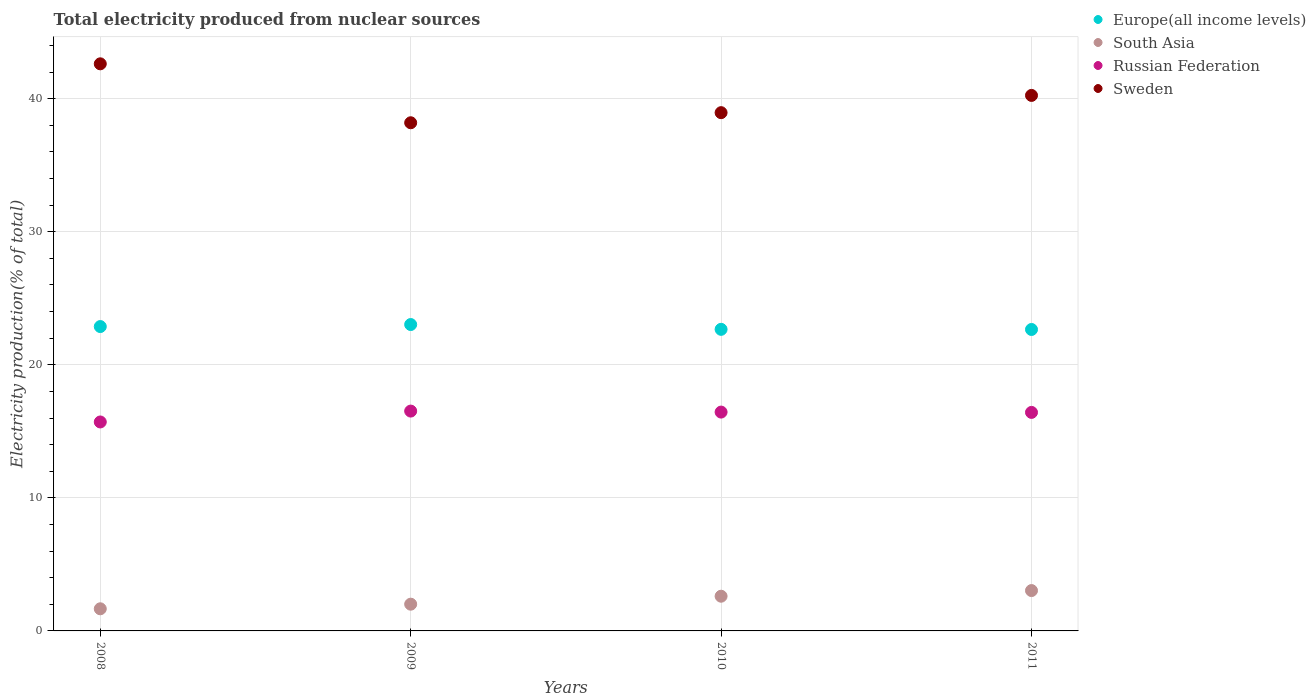Is the number of dotlines equal to the number of legend labels?
Your answer should be very brief. Yes. What is the total electricity produced in Russian Federation in 2011?
Your answer should be very brief. 16.42. Across all years, what is the maximum total electricity produced in Sweden?
Your answer should be very brief. 42.62. Across all years, what is the minimum total electricity produced in South Asia?
Provide a short and direct response. 1.66. In which year was the total electricity produced in Sweden maximum?
Your answer should be compact. 2008. In which year was the total electricity produced in Europe(all income levels) minimum?
Provide a succinct answer. 2011. What is the total total electricity produced in Sweden in the graph?
Keep it short and to the point. 160.02. What is the difference between the total electricity produced in Europe(all income levels) in 2008 and that in 2010?
Give a very brief answer. 0.21. What is the difference between the total electricity produced in Russian Federation in 2011 and the total electricity produced in Europe(all income levels) in 2009?
Your answer should be very brief. -6.6. What is the average total electricity produced in South Asia per year?
Offer a very short reply. 2.33. In the year 2009, what is the difference between the total electricity produced in Sweden and total electricity produced in Russian Federation?
Your answer should be compact. 21.67. In how many years, is the total electricity produced in South Asia greater than 20 %?
Keep it short and to the point. 0. What is the ratio of the total electricity produced in Sweden in 2010 to that in 2011?
Your answer should be very brief. 0.97. Is the total electricity produced in Europe(all income levels) in 2010 less than that in 2011?
Provide a succinct answer. No. Is the difference between the total electricity produced in Sweden in 2008 and 2011 greater than the difference between the total electricity produced in Russian Federation in 2008 and 2011?
Make the answer very short. Yes. What is the difference between the highest and the second highest total electricity produced in South Asia?
Offer a very short reply. 0.42. What is the difference between the highest and the lowest total electricity produced in Sweden?
Give a very brief answer. 4.43. Does the total electricity produced in Europe(all income levels) monotonically increase over the years?
Keep it short and to the point. No. What is the difference between two consecutive major ticks on the Y-axis?
Ensure brevity in your answer.  10. Does the graph contain grids?
Provide a succinct answer. Yes. Where does the legend appear in the graph?
Provide a succinct answer. Top right. How many legend labels are there?
Your response must be concise. 4. How are the legend labels stacked?
Give a very brief answer. Vertical. What is the title of the graph?
Your answer should be very brief. Total electricity produced from nuclear sources. Does "Thailand" appear as one of the legend labels in the graph?
Provide a succinct answer. No. What is the label or title of the X-axis?
Offer a terse response. Years. What is the label or title of the Y-axis?
Offer a very short reply. Electricity production(% of total). What is the Electricity production(% of total) of Europe(all income levels) in 2008?
Ensure brevity in your answer.  22.88. What is the Electricity production(% of total) in South Asia in 2008?
Give a very brief answer. 1.66. What is the Electricity production(% of total) in Russian Federation in 2008?
Give a very brief answer. 15.7. What is the Electricity production(% of total) in Sweden in 2008?
Give a very brief answer. 42.62. What is the Electricity production(% of total) in Europe(all income levels) in 2009?
Keep it short and to the point. 23.03. What is the Electricity production(% of total) of South Asia in 2009?
Provide a short and direct response. 2.01. What is the Electricity production(% of total) in Russian Federation in 2009?
Your answer should be very brief. 16.52. What is the Electricity production(% of total) of Sweden in 2009?
Provide a succinct answer. 38.19. What is the Electricity production(% of total) of Europe(all income levels) in 2010?
Provide a succinct answer. 22.67. What is the Electricity production(% of total) of South Asia in 2010?
Offer a very short reply. 2.61. What is the Electricity production(% of total) of Russian Federation in 2010?
Offer a terse response. 16.45. What is the Electricity production(% of total) of Sweden in 2010?
Keep it short and to the point. 38.95. What is the Electricity production(% of total) of Europe(all income levels) in 2011?
Offer a terse response. 22.66. What is the Electricity production(% of total) of South Asia in 2011?
Provide a short and direct response. 3.03. What is the Electricity production(% of total) of Russian Federation in 2011?
Offer a very short reply. 16.42. What is the Electricity production(% of total) of Sweden in 2011?
Make the answer very short. 40.25. Across all years, what is the maximum Electricity production(% of total) in Europe(all income levels)?
Offer a terse response. 23.03. Across all years, what is the maximum Electricity production(% of total) of South Asia?
Give a very brief answer. 3.03. Across all years, what is the maximum Electricity production(% of total) in Russian Federation?
Offer a very short reply. 16.52. Across all years, what is the maximum Electricity production(% of total) of Sweden?
Your answer should be very brief. 42.62. Across all years, what is the minimum Electricity production(% of total) of Europe(all income levels)?
Give a very brief answer. 22.66. Across all years, what is the minimum Electricity production(% of total) in South Asia?
Give a very brief answer. 1.66. Across all years, what is the minimum Electricity production(% of total) of Russian Federation?
Provide a short and direct response. 15.7. Across all years, what is the minimum Electricity production(% of total) of Sweden?
Make the answer very short. 38.19. What is the total Electricity production(% of total) of Europe(all income levels) in the graph?
Provide a succinct answer. 91.23. What is the total Electricity production(% of total) of South Asia in the graph?
Provide a succinct answer. 9.31. What is the total Electricity production(% of total) in Russian Federation in the graph?
Provide a short and direct response. 65.1. What is the total Electricity production(% of total) in Sweden in the graph?
Make the answer very short. 160.02. What is the difference between the Electricity production(% of total) in Europe(all income levels) in 2008 and that in 2009?
Give a very brief answer. -0.15. What is the difference between the Electricity production(% of total) of South Asia in 2008 and that in 2009?
Offer a terse response. -0.35. What is the difference between the Electricity production(% of total) of Russian Federation in 2008 and that in 2009?
Your answer should be compact. -0.82. What is the difference between the Electricity production(% of total) of Sweden in 2008 and that in 2009?
Ensure brevity in your answer.  4.43. What is the difference between the Electricity production(% of total) of Europe(all income levels) in 2008 and that in 2010?
Provide a short and direct response. 0.21. What is the difference between the Electricity production(% of total) in South Asia in 2008 and that in 2010?
Keep it short and to the point. -0.94. What is the difference between the Electricity production(% of total) of Russian Federation in 2008 and that in 2010?
Provide a succinct answer. -0.74. What is the difference between the Electricity production(% of total) in Sweden in 2008 and that in 2010?
Ensure brevity in your answer.  3.67. What is the difference between the Electricity production(% of total) of Europe(all income levels) in 2008 and that in 2011?
Your response must be concise. 0.22. What is the difference between the Electricity production(% of total) in South Asia in 2008 and that in 2011?
Ensure brevity in your answer.  -1.37. What is the difference between the Electricity production(% of total) of Russian Federation in 2008 and that in 2011?
Provide a short and direct response. -0.72. What is the difference between the Electricity production(% of total) in Sweden in 2008 and that in 2011?
Your response must be concise. 2.37. What is the difference between the Electricity production(% of total) of Europe(all income levels) in 2009 and that in 2010?
Offer a terse response. 0.36. What is the difference between the Electricity production(% of total) of South Asia in 2009 and that in 2010?
Make the answer very short. -0.6. What is the difference between the Electricity production(% of total) of Russian Federation in 2009 and that in 2010?
Your answer should be very brief. 0.08. What is the difference between the Electricity production(% of total) in Sweden in 2009 and that in 2010?
Make the answer very short. -0.76. What is the difference between the Electricity production(% of total) of Europe(all income levels) in 2009 and that in 2011?
Your answer should be compact. 0.37. What is the difference between the Electricity production(% of total) in South Asia in 2009 and that in 2011?
Offer a terse response. -1.02. What is the difference between the Electricity production(% of total) of Russian Federation in 2009 and that in 2011?
Provide a succinct answer. 0.1. What is the difference between the Electricity production(% of total) of Sweden in 2009 and that in 2011?
Ensure brevity in your answer.  -2.06. What is the difference between the Electricity production(% of total) in Europe(all income levels) in 2010 and that in 2011?
Give a very brief answer. 0.01. What is the difference between the Electricity production(% of total) in South Asia in 2010 and that in 2011?
Your answer should be very brief. -0.42. What is the difference between the Electricity production(% of total) of Russian Federation in 2010 and that in 2011?
Your answer should be compact. 0.02. What is the difference between the Electricity production(% of total) in Sweden in 2010 and that in 2011?
Offer a very short reply. -1.3. What is the difference between the Electricity production(% of total) of Europe(all income levels) in 2008 and the Electricity production(% of total) of South Asia in 2009?
Give a very brief answer. 20.87. What is the difference between the Electricity production(% of total) of Europe(all income levels) in 2008 and the Electricity production(% of total) of Russian Federation in 2009?
Your answer should be compact. 6.35. What is the difference between the Electricity production(% of total) of Europe(all income levels) in 2008 and the Electricity production(% of total) of Sweden in 2009?
Your answer should be compact. -15.32. What is the difference between the Electricity production(% of total) in South Asia in 2008 and the Electricity production(% of total) in Russian Federation in 2009?
Offer a terse response. -14.86. What is the difference between the Electricity production(% of total) in South Asia in 2008 and the Electricity production(% of total) in Sweden in 2009?
Provide a succinct answer. -36.53. What is the difference between the Electricity production(% of total) in Russian Federation in 2008 and the Electricity production(% of total) in Sweden in 2009?
Your answer should be compact. -22.49. What is the difference between the Electricity production(% of total) in Europe(all income levels) in 2008 and the Electricity production(% of total) in South Asia in 2010?
Your answer should be compact. 20.27. What is the difference between the Electricity production(% of total) of Europe(all income levels) in 2008 and the Electricity production(% of total) of Russian Federation in 2010?
Offer a terse response. 6.43. What is the difference between the Electricity production(% of total) in Europe(all income levels) in 2008 and the Electricity production(% of total) in Sweden in 2010?
Provide a succinct answer. -16.08. What is the difference between the Electricity production(% of total) of South Asia in 2008 and the Electricity production(% of total) of Russian Federation in 2010?
Your response must be concise. -14.78. What is the difference between the Electricity production(% of total) of South Asia in 2008 and the Electricity production(% of total) of Sweden in 2010?
Offer a terse response. -37.29. What is the difference between the Electricity production(% of total) in Russian Federation in 2008 and the Electricity production(% of total) in Sweden in 2010?
Provide a short and direct response. -23.25. What is the difference between the Electricity production(% of total) in Europe(all income levels) in 2008 and the Electricity production(% of total) in South Asia in 2011?
Make the answer very short. 19.84. What is the difference between the Electricity production(% of total) in Europe(all income levels) in 2008 and the Electricity production(% of total) in Russian Federation in 2011?
Your answer should be compact. 6.45. What is the difference between the Electricity production(% of total) of Europe(all income levels) in 2008 and the Electricity production(% of total) of Sweden in 2011?
Provide a succinct answer. -17.37. What is the difference between the Electricity production(% of total) in South Asia in 2008 and the Electricity production(% of total) in Russian Federation in 2011?
Make the answer very short. -14.76. What is the difference between the Electricity production(% of total) in South Asia in 2008 and the Electricity production(% of total) in Sweden in 2011?
Keep it short and to the point. -38.59. What is the difference between the Electricity production(% of total) in Russian Federation in 2008 and the Electricity production(% of total) in Sweden in 2011?
Provide a short and direct response. -24.54. What is the difference between the Electricity production(% of total) of Europe(all income levels) in 2009 and the Electricity production(% of total) of South Asia in 2010?
Give a very brief answer. 20.42. What is the difference between the Electricity production(% of total) in Europe(all income levels) in 2009 and the Electricity production(% of total) in Russian Federation in 2010?
Your response must be concise. 6.58. What is the difference between the Electricity production(% of total) of Europe(all income levels) in 2009 and the Electricity production(% of total) of Sweden in 2010?
Provide a succinct answer. -15.92. What is the difference between the Electricity production(% of total) in South Asia in 2009 and the Electricity production(% of total) in Russian Federation in 2010?
Provide a succinct answer. -14.44. What is the difference between the Electricity production(% of total) of South Asia in 2009 and the Electricity production(% of total) of Sweden in 2010?
Provide a short and direct response. -36.94. What is the difference between the Electricity production(% of total) in Russian Federation in 2009 and the Electricity production(% of total) in Sweden in 2010?
Keep it short and to the point. -22.43. What is the difference between the Electricity production(% of total) of Europe(all income levels) in 2009 and the Electricity production(% of total) of South Asia in 2011?
Give a very brief answer. 20. What is the difference between the Electricity production(% of total) in Europe(all income levels) in 2009 and the Electricity production(% of total) in Russian Federation in 2011?
Your response must be concise. 6.6. What is the difference between the Electricity production(% of total) of Europe(all income levels) in 2009 and the Electricity production(% of total) of Sweden in 2011?
Ensure brevity in your answer.  -17.22. What is the difference between the Electricity production(% of total) in South Asia in 2009 and the Electricity production(% of total) in Russian Federation in 2011?
Provide a succinct answer. -14.41. What is the difference between the Electricity production(% of total) in South Asia in 2009 and the Electricity production(% of total) in Sweden in 2011?
Provide a short and direct response. -38.24. What is the difference between the Electricity production(% of total) of Russian Federation in 2009 and the Electricity production(% of total) of Sweden in 2011?
Provide a succinct answer. -23.73. What is the difference between the Electricity production(% of total) in Europe(all income levels) in 2010 and the Electricity production(% of total) in South Asia in 2011?
Your answer should be very brief. 19.63. What is the difference between the Electricity production(% of total) of Europe(all income levels) in 2010 and the Electricity production(% of total) of Russian Federation in 2011?
Ensure brevity in your answer.  6.24. What is the difference between the Electricity production(% of total) of Europe(all income levels) in 2010 and the Electricity production(% of total) of Sweden in 2011?
Keep it short and to the point. -17.58. What is the difference between the Electricity production(% of total) in South Asia in 2010 and the Electricity production(% of total) in Russian Federation in 2011?
Your response must be concise. -13.82. What is the difference between the Electricity production(% of total) of South Asia in 2010 and the Electricity production(% of total) of Sweden in 2011?
Ensure brevity in your answer.  -37.64. What is the difference between the Electricity production(% of total) of Russian Federation in 2010 and the Electricity production(% of total) of Sweden in 2011?
Your response must be concise. -23.8. What is the average Electricity production(% of total) of Europe(all income levels) per year?
Your response must be concise. 22.81. What is the average Electricity production(% of total) in South Asia per year?
Ensure brevity in your answer.  2.33. What is the average Electricity production(% of total) in Russian Federation per year?
Offer a very short reply. 16.27. What is the average Electricity production(% of total) in Sweden per year?
Offer a terse response. 40. In the year 2008, what is the difference between the Electricity production(% of total) of Europe(all income levels) and Electricity production(% of total) of South Asia?
Keep it short and to the point. 21.21. In the year 2008, what is the difference between the Electricity production(% of total) of Europe(all income levels) and Electricity production(% of total) of Russian Federation?
Provide a short and direct response. 7.17. In the year 2008, what is the difference between the Electricity production(% of total) of Europe(all income levels) and Electricity production(% of total) of Sweden?
Give a very brief answer. -19.75. In the year 2008, what is the difference between the Electricity production(% of total) of South Asia and Electricity production(% of total) of Russian Federation?
Ensure brevity in your answer.  -14.04. In the year 2008, what is the difference between the Electricity production(% of total) in South Asia and Electricity production(% of total) in Sweden?
Your response must be concise. -40.96. In the year 2008, what is the difference between the Electricity production(% of total) of Russian Federation and Electricity production(% of total) of Sweden?
Offer a terse response. -26.92. In the year 2009, what is the difference between the Electricity production(% of total) in Europe(all income levels) and Electricity production(% of total) in South Asia?
Offer a very short reply. 21.02. In the year 2009, what is the difference between the Electricity production(% of total) of Europe(all income levels) and Electricity production(% of total) of Russian Federation?
Your response must be concise. 6.5. In the year 2009, what is the difference between the Electricity production(% of total) of Europe(all income levels) and Electricity production(% of total) of Sweden?
Offer a very short reply. -15.16. In the year 2009, what is the difference between the Electricity production(% of total) of South Asia and Electricity production(% of total) of Russian Federation?
Ensure brevity in your answer.  -14.51. In the year 2009, what is the difference between the Electricity production(% of total) of South Asia and Electricity production(% of total) of Sweden?
Offer a very short reply. -36.18. In the year 2009, what is the difference between the Electricity production(% of total) of Russian Federation and Electricity production(% of total) of Sweden?
Make the answer very short. -21.67. In the year 2010, what is the difference between the Electricity production(% of total) in Europe(all income levels) and Electricity production(% of total) in South Asia?
Your answer should be compact. 20.06. In the year 2010, what is the difference between the Electricity production(% of total) in Europe(all income levels) and Electricity production(% of total) in Russian Federation?
Keep it short and to the point. 6.22. In the year 2010, what is the difference between the Electricity production(% of total) of Europe(all income levels) and Electricity production(% of total) of Sweden?
Your answer should be very brief. -16.28. In the year 2010, what is the difference between the Electricity production(% of total) of South Asia and Electricity production(% of total) of Russian Federation?
Keep it short and to the point. -13.84. In the year 2010, what is the difference between the Electricity production(% of total) of South Asia and Electricity production(% of total) of Sweden?
Give a very brief answer. -36.34. In the year 2010, what is the difference between the Electricity production(% of total) in Russian Federation and Electricity production(% of total) in Sweden?
Ensure brevity in your answer.  -22.5. In the year 2011, what is the difference between the Electricity production(% of total) of Europe(all income levels) and Electricity production(% of total) of South Asia?
Your response must be concise. 19.62. In the year 2011, what is the difference between the Electricity production(% of total) in Europe(all income levels) and Electricity production(% of total) in Russian Federation?
Offer a very short reply. 6.23. In the year 2011, what is the difference between the Electricity production(% of total) in Europe(all income levels) and Electricity production(% of total) in Sweden?
Keep it short and to the point. -17.59. In the year 2011, what is the difference between the Electricity production(% of total) of South Asia and Electricity production(% of total) of Russian Federation?
Offer a terse response. -13.39. In the year 2011, what is the difference between the Electricity production(% of total) in South Asia and Electricity production(% of total) in Sweden?
Make the answer very short. -37.22. In the year 2011, what is the difference between the Electricity production(% of total) in Russian Federation and Electricity production(% of total) in Sweden?
Offer a terse response. -23.82. What is the ratio of the Electricity production(% of total) of Europe(all income levels) in 2008 to that in 2009?
Keep it short and to the point. 0.99. What is the ratio of the Electricity production(% of total) of South Asia in 2008 to that in 2009?
Offer a very short reply. 0.83. What is the ratio of the Electricity production(% of total) in Russian Federation in 2008 to that in 2009?
Keep it short and to the point. 0.95. What is the ratio of the Electricity production(% of total) in Sweden in 2008 to that in 2009?
Offer a terse response. 1.12. What is the ratio of the Electricity production(% of total) in Europe(all income levels) in 2008 to that in 2010?
Keep it short and to the point. 1.01. What is the ratio of the Electricity production(% of total) of South Asia in 2008 to that in 2010?
Make the answer very short. 0.64. What is the ratio of the Electricity production(% of total) in Russian Federation in 2008 to that in 2010?
Your response must be concise. 0.95. What is the ratio of the Electricity production(% of total) in Sweden in 2008 to that in 2010?
Provide a short and direct response. 1.09. What is the ratio of the Electricity production(% of total) of Europe(all income levels) in 2008 to that in 2011?
Keep it short and to the point. 1.01. What is the ratio of the Electricity production(% of total) of South Asia in 2008 to that in 2011?
Provide a short and direct response. 0.55. What is the ratio of the Electricity production(% of total) of Russian Federation in 2008 to that in 2011?
Offer a terse response. 0.96. What is the ratio of the Electricity production(% of total) in Sweden in 2008 to that in 2011?
Make the answer very short. 1.06. What is the ratio of the Electricity production(% of total) of Europe(all income levels) in 2009 to that in 2010?
Provide a short and direct response. 1.02. What is the ratio of the Electricity production(% of total) in South Asia in 2009 to that in 2010?
Offer a very short reply. 0.77. What is the ratio of the Electricity production(% of total) of Russian Federation in 2009 to that in 2010?
Provide a short and direct response. 1. What is the ratio of the Electricity production(% of total) in Sweden in 2009 to that in 2010?
Your response must be concise. 0.98. What is the ratio of the Electricity production(% of total) in Europe(all income levels) in 2009 to that in 2011?
Make the answer very short. 1.02. What is the ratio of the Electricity production(% of total) of South Asia in 2009 to that in 2011?
Your answer should be compact. 0.66. What is the ratio of the Electricity production(% of total) of Russian Federation in 2009 to that in 2011?
Provide a succinct answer. 1.01. What is the ratio of the Electricity production(% of total) of Sweden in 2009 to that in 2011?
Provide a succinct answer. 0.95. What is the ratio of the Electricity production(% of total) in South Asia in 2010 to that in 2011?
Your answer should be compact. 0.86. What is the ratio of the Electricity production(% of total) of Sweden in 2010 to that in 2011?
Give a very brief answer. 0.97. What is the difference between the highest and the second highest Electricity production(% of total) in Europe(all income levels)?
Your answer should be compact. 0.15. What is the difference between the highest and the second highest Electricity production(% of total) in South Asia?
Offer a very short reply. 0.42. What is the difference between the highest and the second highest Electricity production(% of total) in Russian Federation?
Your answer should be compact. 0.08. What is the difference between the highest and the second highest Electricity production(% of total) in Sweden?
Your answer should be compact. 2.37. What is the difference between the highest and the lowest Electricity production(% of total) of Europe(all income levels)?
Your answer should be compact. 0.37. What is the difference between the highest and the lowest Electricity production(% of total) of South Asia?
Ensure brevity in your answer.  1.37. What is the difference between the highest and the lowest Electricity production(% of total) of Russian Federation?
Your answer should be very brief. 0.82. What is the difference between the highest and the lowest Electricity production(% of total) in Sweden?
Your answer should be very brief. 4.43. 